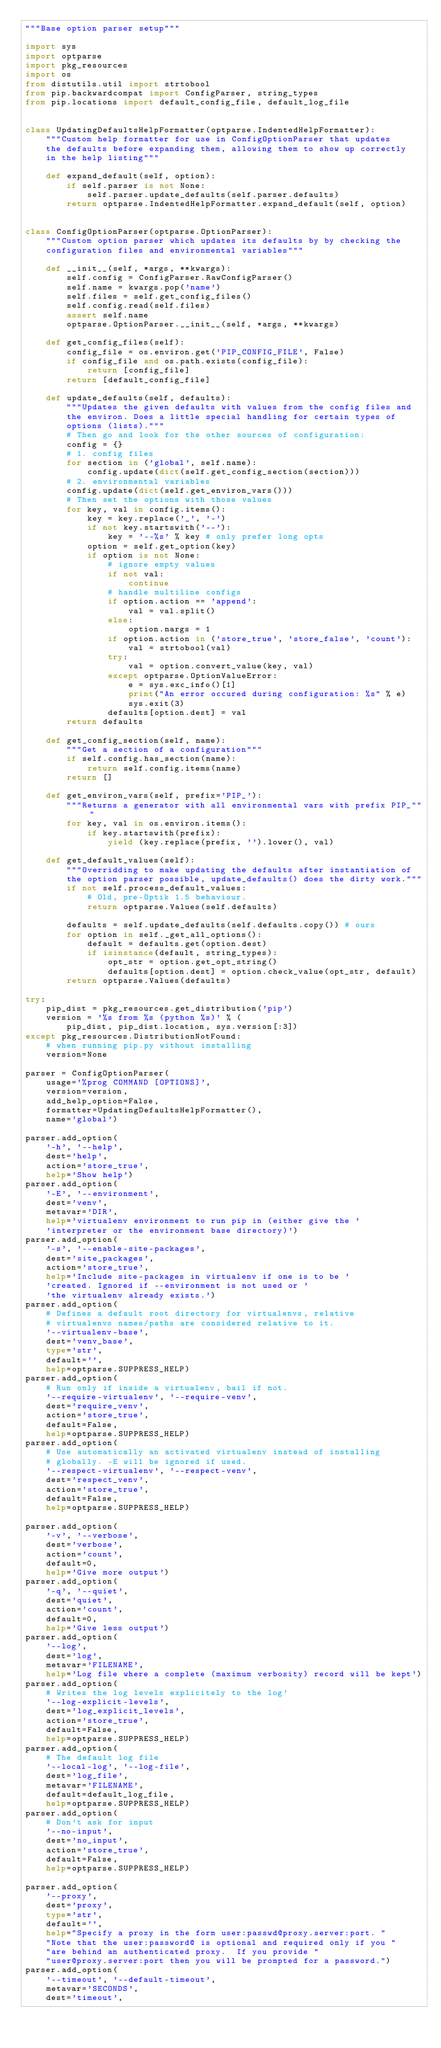<code> <loc_0><loc_0><loc_500><loc_500><_Python_>"""Base option parser setup"""

import sys
import optparse
import pkg_resources
import os
from distutils.util import strtobool
from pip.backwardcompat import ConfigParser, string_types
from pip.locations import default_config_file, default_log_file


class UpdatingDefaultsHelpFormatter(optparse.IndentedHelpFormatter):
    """Custom help formatter for use in ConfigOptionParser that updates
    the defaults before expanding them, allowing them to show up correctly
    in the help listing"""

    def expand_default(self, option):
        if self.parser is not None:
            self.parser.update_defaults(self.parser.defaults)
        return optparse.IndentedHelpFormatter.expand_default(self, option)


class ConfigOptionParser(optparse.OptionParser):
    """Custom option parser which updates its defaults by by checking the
    configuration files and environmental variables"""

    def __init__(self, *args, **kwargs):
        self.config = ConfigParser.RawConfigParser()
        self.name = kwargs.pop('name')
        self.files = self.get_config_files()
        self.config.read(self.files)
        assert self.name
        optparse.OptionParser.__init__(self, *args, **kwargs)

    def get_config_files(self):
        config_file = os.environ.get('PIP_CONFIG_FILE', False)
        if config_file and os.path.exists(config_file):
            return [config_file]
        return [default_config_file]

    def update_defaults(self, defaults):
        """Updates the given defaults with values from the config files and
        the environ. Does a little special handling for certain types of
        options (lists)."""
        # Then go and look for the other sources of configuration:
        config = {}
        # 1. config files
        for section in ('global', self.name):
            config.update(dict(self.get_config_section(section)))
        # 2. environmental variables
        config.update(dict(self.get_environ_vars()))
        # Then set the options with those values
        for key, val in config.items():
            key = key.replace('_', '-')
            if not key.startswith('--'):
                key = '--%s' % key # only prefer long opts
            option = self.get_option(key)
            if option is not None:
                # ignore empty values
                if not val:
                    continue
                # handle multiline configs
                if option.action == 'append':
                    val = val.split()
                else:
                    option.nargs = 1
                if option.action in ('store_true', 'store_false', 'count'):
                    val = strtobool(val)
                try:
                    val = option.convert_value(key, val)
                except optparse.OptionValueError:
                    e = sys.exc_info()[1]
                    print("An error occured during configuration: %s" % e)
                    sys.exit(3)
                defaults[option.dest] = val
        return defaults

    def get_config_section(self, name):
        """Get a section of a configuration"""
        if self.config.has_section(name):
            return self.config.items(name)
        return []

    def get_environ_vars(self, prefix='PIP_'):
        """Returns a generator with all environmental vars with prefix PIP_"""
        for key, val in os.environ.items():
            if key.startswith(prefix):
                yield (key.replace(prefix, '').lower(), val)

    def get_default_values(self):
        """Overridding to make updating the defaults after instantiation of
        the option parser possible, update_defaults() does the dirty work."""
        if not self.process_default_values:
            # Old, pre-Optik 1.5 behaviour.
            return optparse.Values(self.defaults)

        defaults = self.update_defaults(self.defaults.copy()) # ours
        for option in self._get_all_options():
            default = defaults.get(option.dest)
            if isinstance(default, string_types):
                opt_str = option.get_opt_string()
                defaults[option.dest] = option.check_value(opt_str, default)
        return optparse.Values(defaults)

try:
    pip_dist = pkg_resources.get_distribution('pip')
    version = '%s from %s (python %s)' % (
        pip_dist, pip_dist.location, sys.version[:3])
except pkg_resources.DistributionNotFound:
    # when running pip.py without installing
    version=None

parser = ConfigOptionParser(
    usage='%prog COMMAND [OPTIONS]',
    version=version,
    add_help_option=False,
    formatter=UpdatingDefaultsHelpFormatter(),
    name='global')

parser.add_option(
    '-h', '--help',
    dest='help',
    action='store_true',
    help='Show help')
parser.add_option(
    '-E', '--environment',
    dest='venv',
    metavar='DIR',
    help='virtualenv environment to run pip in (either give the '
    'interpreter or the environment base directory)')
parser.add_option(
    '-s', '--enable-site-packages',
    dest='site_packages',
    action='store_true',
    help='Include site-packages in virtualenv if one is to be '
    'created. Ignored if --environment is not used or '
    'the virtualenv already exists.')
parser.add_option(
    # Defines a default root directory for virtualenvs, relative
    # virtualenvs names/paths are considered relative to it.
    '--virtualenv-base',
    dest='venv_base',
    type='str',
    default='',
    help=optparse.SUPPRESS_HELP)
parser.add_option(
    # Run only if inside a virtualenv, bail if not.
    '--require-virtualenv', '--require-venv',
    dest='require_venv',
    action='store_true',
    default=False,
    help=optparse.SUPPRESS_HELP)
parser.add_option(
    # Use automatically an activated virtualenv instead of installing
    # globally. -E will be ignored if used.
    '--respect-virtualenv', '--respect-venv',
    dest='respect_venv',
    action='store_true',
    default=False,
    help=optparse.SUPPRESS_HELP)

parser.add_option(
    '-v', '--verbose',
    dest='verbose',
    action='count',
    default=0,
    help='Give more output')
parser.add_option(
    '-q', '--quiet',
    dest='quiet',
    action='count',
    default=0,
    help='Give less output')
parser.add_option(
    '--log',
    dest='log',
    metavar='FILENAME',
    help='Log file where a complete (maximum verbosity) record will be kept')
parser.add_option(
    # Writes the log levels explicitely to the log'
    '--log-explicit-levels',
    dest='log_explicit_levels',
    action='store_true',
    default=False,
    help=optparse.SUPPRESS_HELP)
parser.add_option(
    # The default log file
    '--local-log', '--log-file',
    dest='log_file',
    metavar='FILENAME',
    default=default_log_file,
    help=optparse.SUPPRESS_HELP)
parser.add_option(
    # Don't ask for input
    '--no-input',
    dest='no_input',
    action='store_true',
    default=False,
    help=optparse.SUPPRESS_HELP)

parser.add_option(
    '--proxy',
    dest='proxy',
    type='str',
    default='',
    help="Specify a proxy in the form user:passwd@proxy.server:port. "
    "Note that the user:password@ is optional and required only if you "
    "are behind an authenticated proxy.  If you provide "
    "user@proxy.server:port then you will be prompted for a password.")
parser.add_option(
    '--timeout', '--default-timeout',
    metavar='SECONDS',
    dest='timeout',</code> 